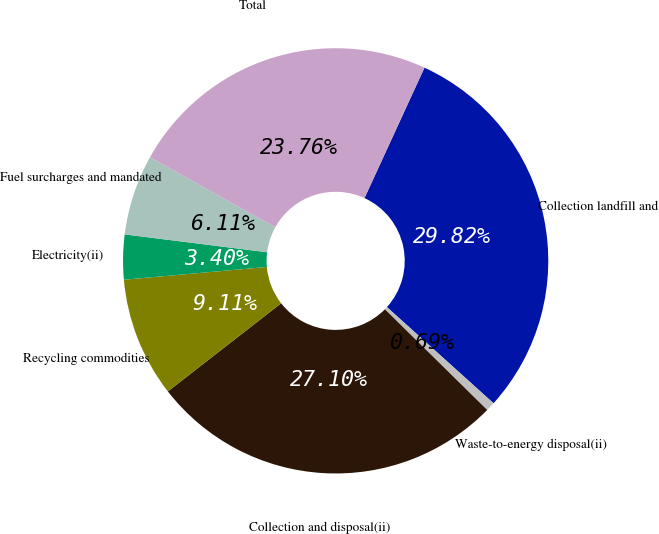Convert chart to OTSL. <chart><loc_0><loc_0><loc_500><loc_500><pie_chart><fcel>Collection landfill and<fcel>Waste-to-energy disposal(ii)<fcel>Collection and disposal(ii)<fcel>Recycling commodities<fcel>Electricity(ii)<fcel>Fuel surcharges and mandated<fcel>Total<nl><fcel>29.82%<fcel>0.69%<fcel>27.1%<fcel>9.11%<fcel>3.4%<fcel>6.11%<fcel>23.76%<nl></chart> 